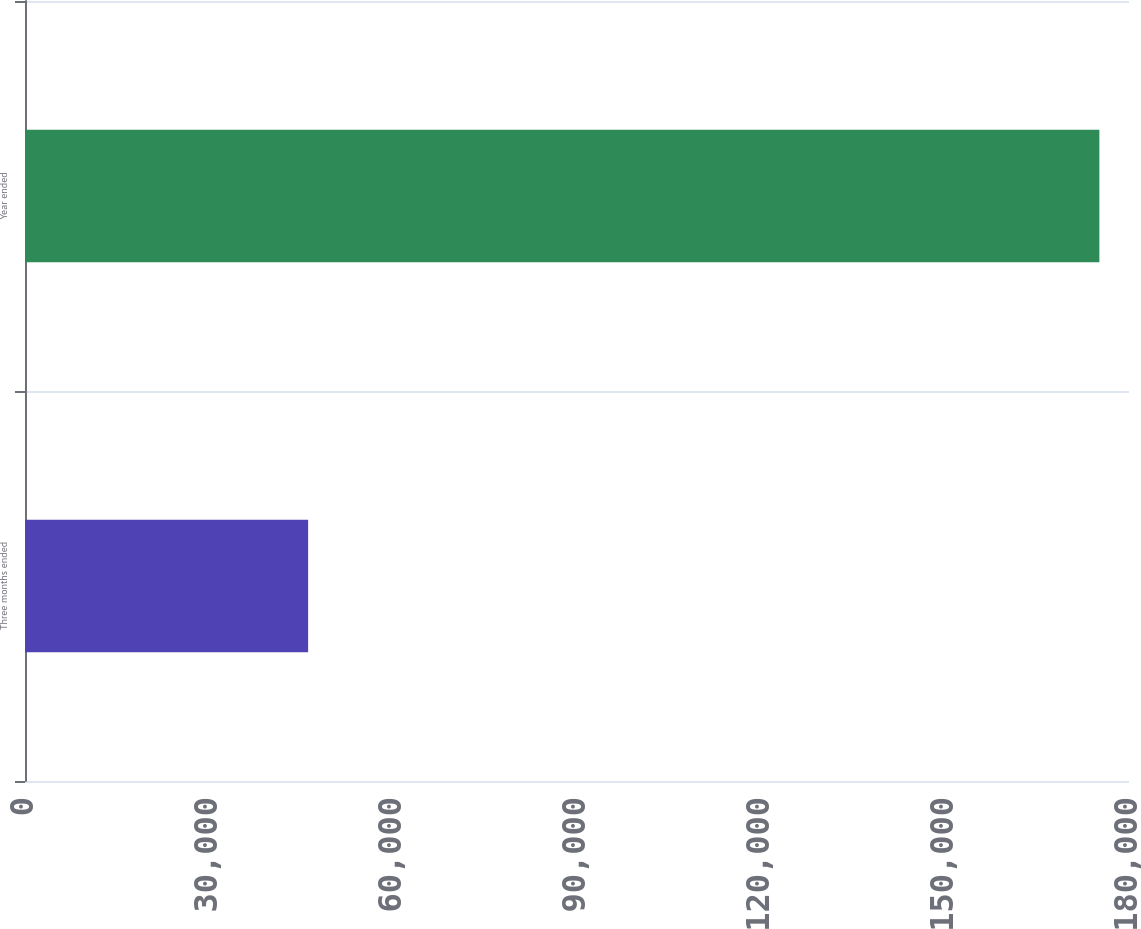Convert chart to OTSL. <chart><loc_0><loc_0><loc_500><loc_500><bar_chart><fcel>Three months ended<fcel>Year ended<nl><fcel>46160<fcel>175170<nl></chart> 